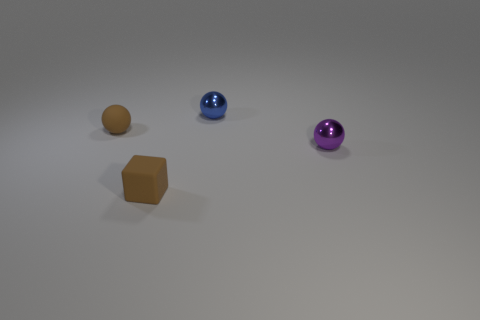There is another matte object that is the same shape as the purple thing; what is its color?
Your answer should be very brief. Brown. What is the shape of the small matte thing right of the small brown matte sphere?
Your response must be concise. Cube. Are there any tiny shiny spheres behind the tiny purple metallic object?
Offer a very short reply. Yes. The other ball that is made of the same material as the small blue sphere is what color?
Offer a very short reply. Purple. There is a small block left of the small blue ball; is its color the same as the tiny ball that is left of the tiny blue shiny ball?
Your answer should be compact. Yes. What number of cylinders are cyan matte things or small purple metallic objects?
Offer a very short reply. 0. Is the number of blue spheres that are on the left side of the small brown rubber cube the same as the number of large gray metallic cubes?
Your answer should be compact. Yes. What is the material of the small thing behind the matte thing behind the tiny brown matte thing that is in front of the tiny purple thing?
Keep it short and to the point. Metal. How many things are either tiny brown rubber objects that are to the left of the cube or small blue metal blocks?
Offer a terse response. 1. What number of objects are brown things or tiny metallic things behind the brown matte ball?
Provide a succinct answer. 3. 